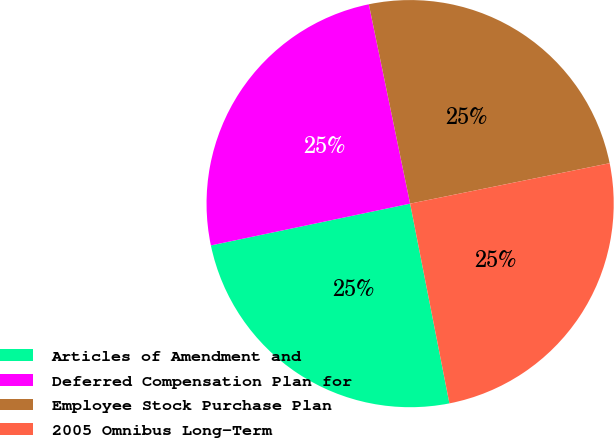Convert chart. <chart><loc_0><loc_0><loc_500><loc_500><pie_chart><fcel>Articles of Amendment and<fcel>Deferred Compensation Plan for<fcel>Employee Stock Purchase Plan<fcel>2005 Omnibus Long-Term<nl><fcel>24.8%<fcel>25.04%<fcel>25.07%<fcel>25.09%<nl></chart> 